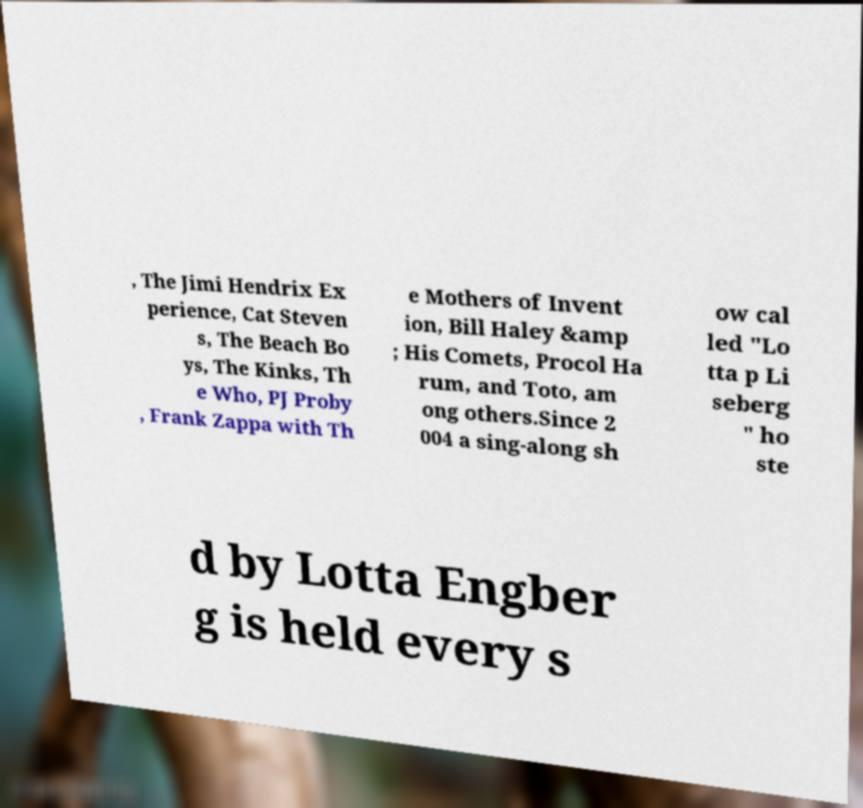I need the written content from this picture converted into text. Can you do that? , The Jimi Hendrix Ex perience, Cat Steven s, The Beach Bo ys, The Kinks, Th e Who, PJ Proby , Frank Zappa with Th e Mothers of Invent ion, Bill Haley &amp ; His Comets, Procol Ha rum, and Toto, am ong others.Since 2 004 a sing-along sh ow cal led "Lo tta p Li seberg " ho ste d by Lotta Engber g is held every s 